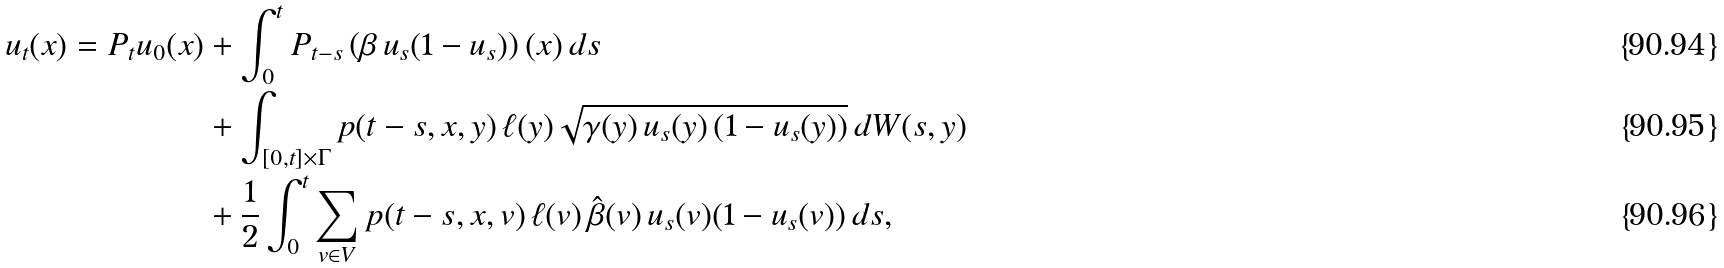<formula> <loc_0><loc_0><loc_500><loc_500>u _ { t } ( x ) = P _ { t } u _ { 0 } ( x ) & + \int _ { 0 } ^ { t } P _ { t - s } \left ( \beta \, u _ { s } ( 1 - u _ { s } ) \right ) ( x ) \, d s \\ & + \int _ { [ 0 , t ] \times \Gamma } p ( t - s , x , y ) \, \ell ( y ) \sqrt { \gamma ( y ) \, u _ { s } ( y ) \left ( 1 - u _ { s } ( y ) \right ) } \, d W ( s , y ) \\ & + \frac { 1 } { 2 } \int _ { 0 } ^ { t } \sum _ { v \in V } p ( t - s , x , v ) \, \ell ( v ) \, \hat { \beta } ( v ) \, u _ { s } ( v ) ( 1 - u _ { s } ( v ) ) \, d s ,</formula> 